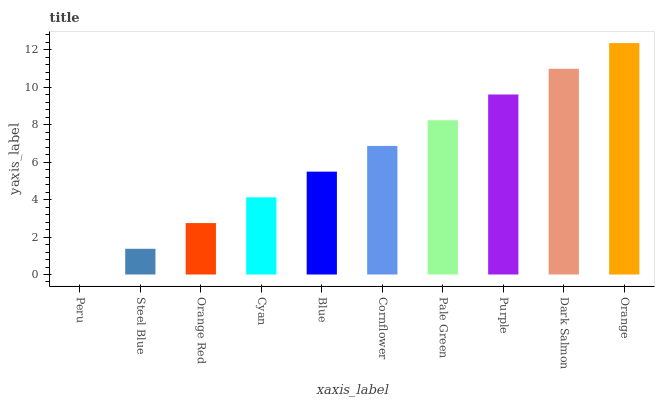Is Peru the minimum?
Answer yes or no. Yes. Is Orange the maximum?
Answer yes or no. Yes. Is Steel Blue the minimum?
Answer yes or no. No. Is Steel Blue the maximum?
Answer yes or no. No. Is Steel Blue greater than Peru?
Answer yes or no. Yes. Is Peru less than Steel Blue?
Answer yes or no. Yes. Is Peru greater than Steel Blue?
Answer yes or no. No. Is Steel Blue less than Peru?
Answer yes or no. No. Is Cornflower the high median?
Answer yes or no. Yes. Is Blue the low median?
Answer yes or no. Yes. Is Steel Blue the high median?
Answer yes or no. No. Is Steel Blue the low median?
Answer yes or no. No. 